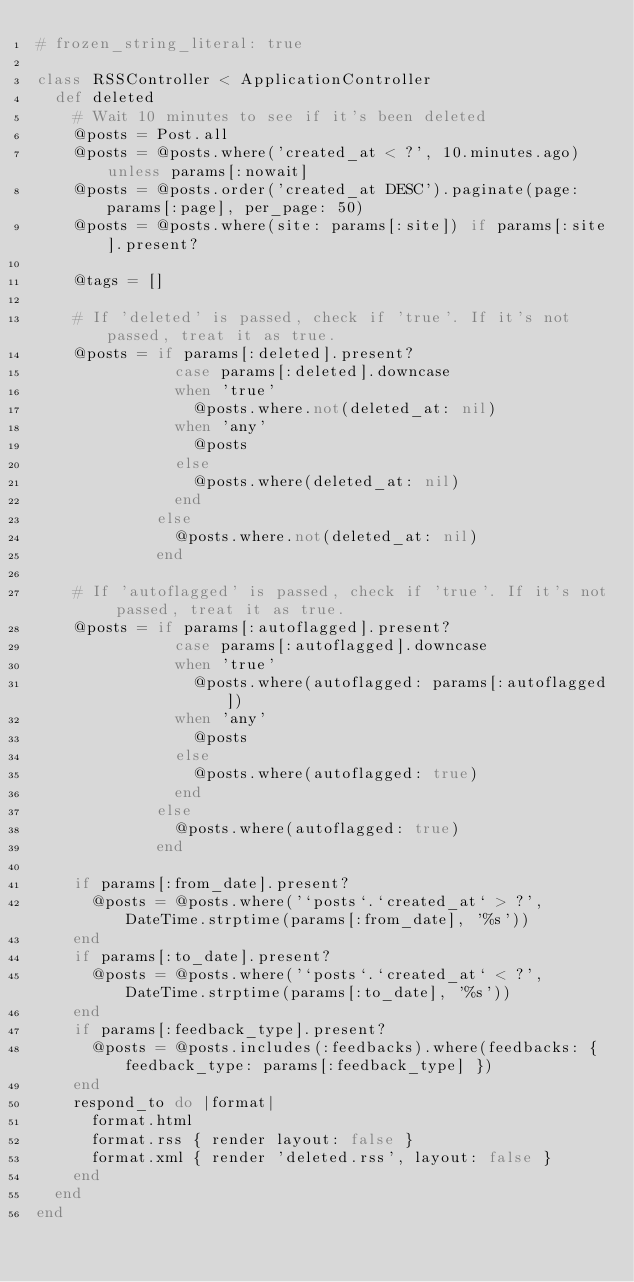Convert code to text. <code><loc_0><loc_0><loc_500><loc_500><_Ruby_># frozen_string_literal: true

class RSSController < ApplicationController
  def deleted
    # Wait 10 minutes to see if it's been deleted
    @posts = Post.all
    @posts = @posts.where('created_at < ?', 10.minutes.ago) unless params[:nowait]
    @posts = @posts.order('created_at DESC').paginate(page: params[:page], per_page: 50)
    @posts = @posts.where(site: params[:site]) if params[:site].present?

    @tags = []

    # If 'deleted' is passed, check if 'true'. If it's not passed, treat it as true.
    @posts = if params[:deleted].present?
               case params[:deleted].downcase
               when 'true'
                 @posts.where.not(deleted_at: nil)
               when 'any'
                 @posts
               else
                 @posts.where(deleted_at: nil)
               end
             else
               @posts.where.not(deleted_at: nil)
             end

    # If 'autoflagged' is passed, check if 'true'. If it's not passed, treat it as true.
    @posts = if params[:autoflagged].present?
               case params[:autoflagged].downcase
               when 'true'
                 @posts.where(autoflagged: params[:autoflagged])
               when 'any'
                 @posts
               else
                 @posts.where(autoflagged: true)
               end
             else
               @posts.where(autoflagged: true)
             end

    if params[:from_date].present?
      @posts = @posts.where('`posts`.`created_at` > ?', DateTime.strptime(params[:from_date], '%s'))
    end
    if params[:to_date].present?
      @posts = @posts.where('`posts`.`created_at` < ?', DateTime.strptime(params[:to_date], '%s'))
    end
    if params[:feedback_type].present?
      @posts = @posts.includes(:feedbacks).where(feedbacks: { feedback_type: params[:feedback_type] })
    end
    respond_to do |format|
      format.html
      format.rss { render layout: false }
      format.xml { render 'deleted.rss', layout: false }
    end
  end
end
</code> 